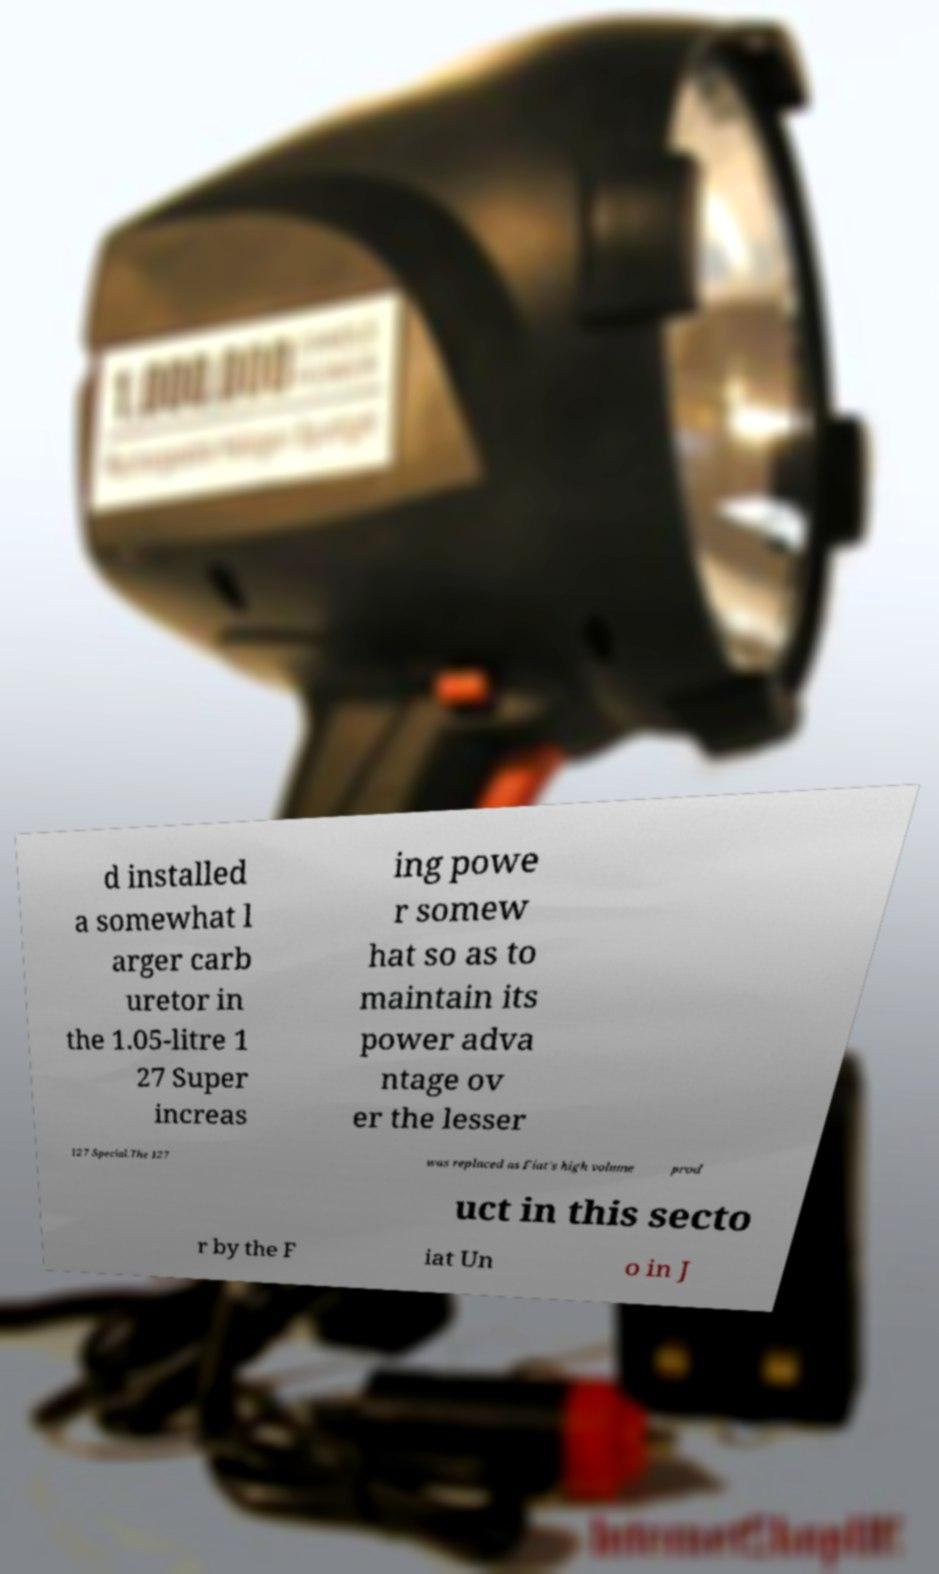Can you read and provide the text displayed in the image?This photo seems to have some interesting text. Can you extract and type it out for me? d installed a somewhat l arger carb uretor in the 1.05-litre 1 27 Super increas ing powe r somew hat so as to maintain its power adva ntage ov er the lesser 127 Special.The 127 was replaced as Fiat's high volume prod uct in this secto r by the F iat Un o in J 